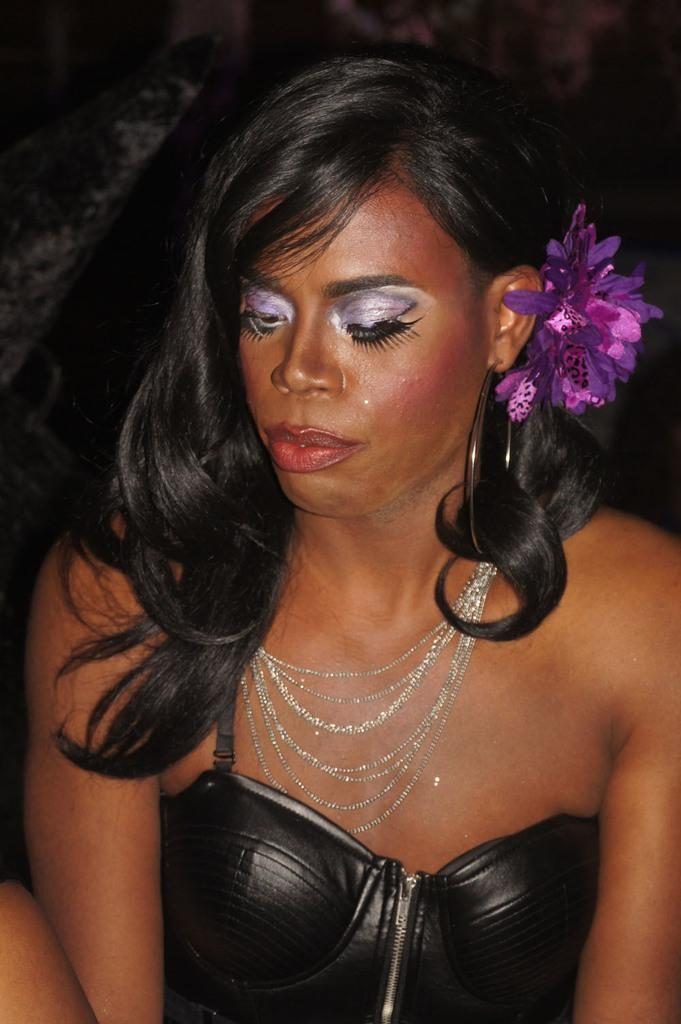Who is present in the image? There is a woman in the image. What is the woman wearing? The woman is wearing a black dress. What can be seen in the background of the image? The background of the image is dark. What type of chair is the woman sitting on in the image? There is no chair present in the image; the woman is not sitting. 